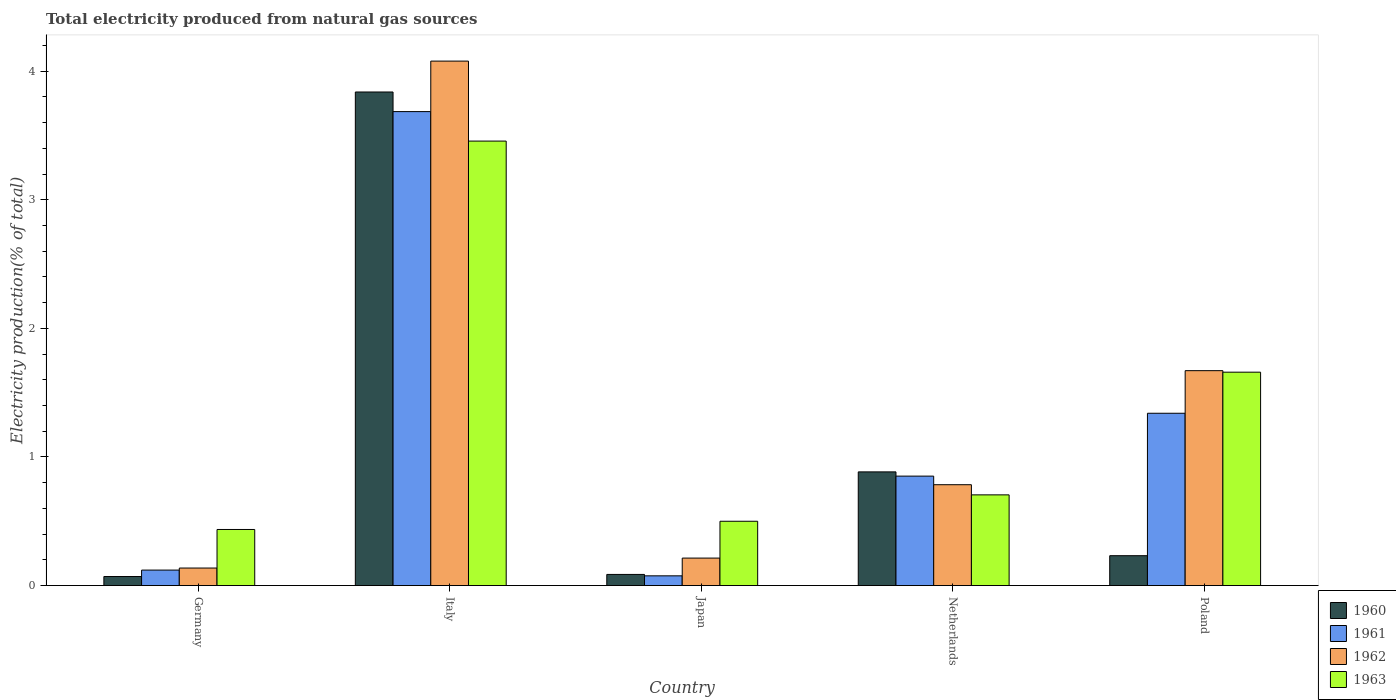How many groups of bars are there?
Make the answer very short. 5. Are the number of bars per tick equal to the number of legend labels?
Your answer should be compact. Yes. How many bars are there on the 3rd tick from the right?
Make the answer very short. 4. What is the total electricity produced in 1962 in Japan?
Offer a terse response. 0.21. Across all countries, what is the maximum total electricity produced in 1962?
Offer a very short reply. 4.08. Across all countries, what is the minimum total electricity produced in 1962?
Your answer should be compact. 0.14. In which country was the total electricity produced in 1960 minimum?
Give a very brief answer. Germany. What is the total total electricity produced in 1961 in the graph?
Provide a succinct answer. 6.07. What is the difference between the total electricity produced in 1961 in Germany and that in Italy?
Offer a terse response. -3.57. What is the difference between the total electricity produced in 1961 in Poland and the total electricity produced in 1963 in Japan?
Provide a short and direct response. 0.84. What is the average total electricity produced in 1960 per country?
Offer a very short reply. 1.02. What is the difference between the total electricity produced of/in 1963 and total electricity produced of/in 1960 in Poland?
Provide a succinct answer. 1.43. What is the ratio of the total electricity produced in 1960 in Germany to that in Japan?
Your response must be concise. 0.81. What is the difference between the highest and the second highest total electricity produced in 1962?
Provide a short and direct response. -0.89. What is the difference between the highest and the lowest total electricity produced in 1960?
Your response must be concise. 3.77. In how many countries, is the total electricity produced in 1960 greater than the average total electricity produced in 1960 taken over all countries?
Make the answer very short. 1. Is the sum of the total electricity produced in 1962 in Italy and Japan greater than the maximum total electricity produced in 1961 across all countries?
Your answer should be very brief. Yes. Is it the case that in every country, the sum of the total electricity produced in 1963 and total electricity produced in 1962 is greater than the sum of total electricity produced in 1960 and total electricity produced in 1961?
Offer a terse response. No. What does the 2nd bar from the left in Italy represents?
Offer a terse response. 1961. What does the 3rd bar from the right in Germany represents?
Your response must be concise. 1961. Is it the case that in every country, the sum of the total electricity produced in 1962 and total electricity produced in 1963 is greater than the total electricity produced in 1961?
Offer a very short reply. Yes. Are all the bars in the graph horizontal?
Provide a short and direct response. No. How many countries are there in the graph?
Provide a short and direct response. 5. What is the difference between two consecutive major ticks on the Y-axis?
Your response must be concise. 1. What is the title of the graph?
Offer a terse response. Total electricity produced from natural gas sources. What is the label or title of the Y-axis?
Make the answer very short. Electricity production(% of total). What is the Electricity production(% of total) of 1960 in Germany?
Offer a very short reply. 0.07. What is the Electricity production(% of total) in 1961 in Germany?
Provide a short and direct response. 0.12. What is the Electricity production(% of total) in 1962 in Germany?
Provide a short and direct response. 0.14. What is the Electricity production(% of total) in 1963 in Germany?
Provide a short and direct response. 0.44. What is the Electricity production(% of total) in 1960 in Italy?
Make the answer very short. 3.84. What is the Electricity production(% of total) in 1961 in Italy?
Provide a succinct answer. 3.69. What is the Electricity production(% of total) in 1962 in Italy?
Provide a succinct answer. 4.08. What is the Electricity production(% of total) in 1963 in Italy?
Ensure brevity in your answer.  3.46. What is the Electricity production(% of total) of 1960 in Japan?
Provide a succinct answer. 0.09. What is the Electricity production(% of total) of 1961 in Japan?
Keep it short and to the point. 0.08. What is the Electricity production(% of total) of 1962 in Japan?
Offer a terse response. 0.21. What is the Electricity production(% of total) in 1963 in Japan?
Your answer should be very brief. 0.5. What is the Electricity production(% of total) in 1960 in Netherlands?
Your response must be concise. 0.88. What is the Electricity production(% of total) in 1961 in Netherlands?
Your response must be concise. 0.85. What is the Electricity production(% of total) of 1962 in Netherlands?
Provide a short and direct response. 0.78. What is the Electricity production(% of total) of 1963 in Netherlands?
Ensure brevity in your answer.  0.71. What is the Electricity production(% of total) of 1960 in Poland?
Your answer should be compact. 0.23. What is the Electricity production(% of total) in 1961 in Poland?
Offer a very short reply. 1.34. What is the Electricity production(% of total) of 1962 in Poland?
Give a very brief answer. 1.67. What is the Electricity production(% of total) of 1963 in Poland?
Keep it short and to the point. 1.66. Across all countries, what is the maximum Electricity production(% of total) of 1960?
Your response must be concise. 3.84. Across all countries, what is the maximum Electricity production(% of total) of 1961?
Provide a short and direct response. 3.69. Across all countries, what is the maximum Electricity production(% of total) of 1962?
Provide a succinct answer. 4.08. Across all countries, what is the maximum Electricity production(% of total) of 1963?
Provide a succinct answer. 3.46. Across all countries, what is the minimum Electricity production(% of total) of 1960?
Provide a succinct answer. 0.07. Across all countries, what is the minimum Electricity production(% of total) of 1961?
Give a very brief answer. 0.08. Across all countries, what is the minimum Electricity production(% of total) in 1962?
Ensure brevity in your answer.  0.14. Across all countries, what is the minimum Electricity production(% of total) of 1963?
Keep it short and to the point. 0.44. What is the total Electricity production(% of total) of 1960 in the graph?
Ensure brevity in your answer.  5.11. What is the total Electricity production(% of total) in 1961 in the graph?
Your answer should be compact. 6.07. What is the total Electricity production(% of total) of 1962 in the graph?
Offer a terse response. 6.88. What is the total Electricity production(% of total) in 1963 in the graph?
Your answer should be very brief. 6.76. What is the difference between the Electricity production(% of total) in 1960 in Germany and that in Italy?
Keep it short and to the point. -3.77. What is the difference between the Electricity production(% of total) in 1961 in Germany and that in Italy?
Your answer should be very brief. -3.57. What is the difference between the Electricity production(% of total) in 1962 in Germany and that in Italy?
Your answer should be very brief. -3.94. What is the difference between the Electricity production(% of total) of 1963 in Germany and that in Italy?
Keep it short and to the point. -3.02. What is the difference between the Electricity production(% of total) of 1960 in Germany and that in Japan?
Provide a short and direct response. -0.02. What is the difference between the Electricity production(% of total) of 1961 in Germany and that in Japan?
Give a very brief answer. 0.04. What is the difference between the Electricity production(% of total) of 1962 in Germany and that in Japan?
Ensure brevity in your answer.  -0.08. What is the difference between the Electricity production(% of total) in 1963 in Germany and that in Japan?
Ensure brevity in your answer.  -0.06. What is the difference between the Electricity production(% of total) in 1960 in Germany and that in Netherlands?
Make the answer very short. -0.81. What is the difference between the Electricity production(% of total) in 1961 in Germany and that in Netherlands?
Give a very brief answer. -0.73. What is the difference between the Electricity production(% of total) of 1962 in Germany and that in Netherlands?
Give a very brief answer. -0.65. What is the difference between the Electricity production(% of total) in 1963 in Germany and that in Netherlands?
Keep it short and to the point. -0.27. What is the difference between the Electricity production(% of total) in 1960 in Germany and that in Poland?
Give a very brief answer. -0.16. What is the difference between the Electricity production(% of total) of 1961 in Germany and that in Poland?
Keep it short and to the point. -1.22. What is the difference between the Electricity production(% of total) in 1962 in Germany and that in Poland?
Make the answer very short. -1.53. What is the difference between the Electricity production(% of total) of 1963 in Germany and that in Poland?
Your answer should be very brief. -1.22. What is the difference between the Electricity production(% of total) in 1960 in Italy and that in Japan?
Your answer should be compact. 3.75. What is the difference between the Electricity production(% of total) in 1961 in Italy and that in Japan?
Keep it short and to the point. 3.61. What is the difference between the Electricity production(% of total) in 1962 in Italy and that in Japan?
Give a very brief answer. 3.86. What is the difference between the Electricity production(% of total) in 1963 in Italy and that in Japan?
Offer a terse response. 2.96. What is the difference between the Electricity production(% of total) in 1960 in Italy and that in Netherlands?
Your answer should be very brief. 2.95. What is the difference between the Electricity production(% of total) of 1961 in Italy and that in Netherlands?
Keep it short and to the point. 2.83. What is the difference between the Electricity production(% of total) of 1962 in Italy and that in Netherlands?
Offer a very short reply. 3.29. What is the difference between the Electricity production(% of total) in 1963 in Italy and that in Netherlands?
Offer a very short reply. 2.75. What is the difference between the Electricity production(% of total) of 1960 in Italy and that in Poland?
Offer a terse response. 3.61. What is the difference between the Electricity production(% of total) in 1961 in Italy and that in Poland?
Make the answer very short. 2.35. What is the difference between the Electricity production(% of total) in 1962 in Italy and that in Poland?
Provide a short and direct response. 2.41. What is the difference between the Electricity production(% of total) of 1963 in Italy and that in Poland?
Give a very brief answer. 1.8. What is the difference between the Electricity production(% of total) of 1960 in Japan and that in Netherlands?
Your response must be concise. -0.8. What is the difference between the Electricity production(% of total) in 1961 in Japan and that in Netherlands?
Your answer should be very brief. -0.78. What is the difference between the Electricity production(% of total) in 1962 in Japan and that in Netherlands?
Give a very brief answer. -0.57. What is the difference between the Electricity production(% of total) of 1963 in Japan and that in Netherlands?
Ensure brevity in your answer.  -0.21. What is the difference between the Electricity production(% of total) in 1960 in Japan and that in Poland?
Your answer should be compact. -0.15. What is the difference between the Electricity production(% of total) in 1961 in Japan and that in Poland?
Your answer should be very brief. -1.26. What is the difference between the Electricity production(% of total) of 1962 in Japan and that in Poland?
Your response must be concise. -1.46. What is the difference between the Electricity production(% of total) in 1963 in Japan and that in Poland?
Offer a very short reply. -1.16. What is the difference between the Electricity production(% of total) of 1960 in Netherlands and that in Poland?
Provide a succinct answer. 0.65. What is the difference between the Electricity production(% of total) of 1961 in Netherlands and that in Poland?
Your answer should be very brief. -0.49. What is the difference between the Electricity production(% of total) in 1962 in Netherlands and that in Poland?
Give a very brief answer. -0.89. What is the difference between the Electricity production(% of total) of 1963 in Netherlands and that in Poland?
Provide a short and direct response. -0.95. What is the difference between the Electricity production(% of total) of 1960 in Germany and the Electricity production(% of total) of 1961 in Italy?
Your response must be concise. -3.62. What is the difference between the Electricity production(% of total) of 1960 in Germany and the Electricity production(% of total) of 1962 in Italy?
Provide a succinct answer. -4.01. What is the difference between the Electricity production(% of total) in 1960 in Germany and the Electricity production(% of total) in 1963 in Italy?
Make the answer very short. -3.39. What is the difference between the Electricity production(% of total) of 1961 in Germany and the Electricity production(% of total) of 1962 in Italy?
Your answer should be compact. -3.96. What is the difference between the Electricity production(% of total) in 1961 in Germany and the Electricity production(% of total) in 1963 in Italy?
Your response must be concise. -3.34. What is the difference between the Electricity production(% of total) in 1962 in Germany and the Electricity production(% of total) in 1963 in Italy?
Offer a terse response. -3.32. What is the difference between the Electricity production(% of total) in 1960 in Germany and the Electricity production(% of total) in 1961 in Japan?
Give a very brief answer. -0.01. What is the difference between the Electricity production(% of total) of 1960 in Germany and the Electricity production(% of total) of 1962 in Japan?
Give a very brief answer. -0.14. What is the difference between the Electricity production(% of total) of 1960 in Germany and the Electricity production(% of total) of 1963 in Japan?
Give a very brief answer. -0.43. What is the difference between the Electricity production(% of total) of 1961 in Germany and the Electricity production(% of total) of 1962 in Japan?
Ensure brevity in your answer.  -0.09. What is the difference between the Electricity production(% of total) of 1961 in Germany and the Electricity production(% of total) of 1963 in Japan?
Your answer should be very brief. -0.38. What is the difference between the Electricity production(% of total) of 1962 in Germany and the Electricity production(% of total) of 1963 in Japan?
Your response must be concise. -0.36. What is the difference between the Electricity production(% of total) of 1960 in Germany and the Electricity production(% of total) of 1961 in Netherlands?
Offer a very short reply. -0.78. What is the difference between the Electricity production(% of total) of 1960 in Germany and the Electricity production(% of total) of 1962 in Netherlands?
Your answer should be compact. -0.71. What is the difference between the Electricity production(% of total) in 1960 in Germany and the Electricity production(% of total) in 1963 in Netherlands?
Your response must be concise. -0.64. What is the difference between the Electricity production(% of total) in 1961 in Germany and the Electricity production(% of total) in 1962 in Netherlands?
Offer a terse response. -0.66. What is the difference between the Electricity production(% of total) in 1961 in Germany and the Electricity production(% of total) in 1963 in Netherlands?
Ensure brevity in your answer.  -0.58. What is the difference between the Electricity production(% of total) of 1962 in Germany and the Electricity production(% of total) of 1963 in Netherlands?
Give a very brief answer. -0.57. What is the difference between the Electricity production(% of total) of 1960 in Germany and the Electricity production(% of total) of 1961 in Poland?
Your answer should be very brief. -1.27. What is the difference between the Electricity production(% of total) of 1960 in Germany and the Electricity production(% of total) of 1962 in Poland?
Offer a very short reply. -1.6. What is the difference between the Electricity production(% of total) of 1960 in Germany and the Electricity production(% of total) of 1963 in Poland?
Provide a succinct answer. -1.59. What is the difference between the Electricity production(% of total) in 1961 in Germany and the Electricity production(% of total) in 1962 in Poland?
Your answer should be compact. -1.55. What is the difference between the Electricity production(% of total) of 1961 in Germany and the Electricity production(% of total) of 1963 in Poland?
Your response must be concise. -1.54. What is the difference between the Electricity production(% of total) of 1962 in Germany and the Electricity production(% of total) of 1963 in Poland?
Offer a very short reply. -1.52. What is the difference between the Electricity production(% of total) in 1960 in Italy and the Electricity production(% of total) in 1961 in Japan?
Give a very brief answer. 3.76. What is the difference between the Electricity production(% of total) of 1960 in Italy and the Electricity production(% of total) of 1962 in Japan?
Offer a very short reply. 3.62. What is the difference between the Electricity production(% of total) of 1960 in Italy and the Electricity production(% of total) of 1963 in Japan?
Give a very brief answer. 3.34. What is the difference between the Electricity production(% of total) in 1961 in Italy and the Electricity production(% of total) in 1962 in Japan?
Ensure brevity in your answer.  3.47. What is the difference between the Electricity production(% of total) in 1961 in Italy and the Electricity production(% of total) in 1963 in Japan?
Offer a terse response. 3.19. What is the difference between the Electricity production(% of total) in 1962 in Italy and the Electricity production(% of total) in 1963 in Japan?
Offer a terse response. 3.58. What is the difference between the Electricity production(% of total) of 1960 in Italy and the Electricity production(% of total) of 1961 in Netherlands?
Ensure brevity in your answer.  2.99. What is the difference between the Electricity production(% of total) in 1960 in Italy and the Electricity production(% of total) in 1962 in Netherlands?
Your response must be concise. 3.05. What is the difference between the Electricity production(% of total) in 1960 in Italy and the Electricity production(% of total) in 1963 in Netherlands?
Provide a succinct answer. 3.13. What is the difference between the Electricity production(% of total) in 1961 in Italy and the Electricity production(% of total) in 1962 in Netherlands?
Make the answer very short. 2.9. What is the difference between the Electricity production(% of total) in 1961 in Italy and the Electricity production(% of total) in 1963 in Netherlands?
Your answer should be compact. 2.98. What is the difference between the Electricity production(% of total) in 1962 in Italy and the Electricity production(% of total) in 1963 in Netherlands?
Provide a short and direct response. 3.37. What is the difference between the Electricity production(% of total) of 1960 in Italy and the Electricity production(% of total) of 1961 in Poland?
Keep it short and to the point. 2.5. What is the difference between the Electricity production(% of total) in 1960 in Italy and the Electricity production(% of total) in 1962 in Poland?
Make the answer very short. 2.17. What is the difference between the Electricity production(% of total) of 1960 in Italy and the Electricity production(% of total) of 1963 in Poland?
Provide a succinct answer. 2.18. What is the difference between the Electricity production(% of total) in 1961 in Italy and the Electricity production(% of total) in 1962 in Poland?
Keep it short and to the point. 2.01. What is the difference between the Electricity production(% of total) in 1961 in Italy and the Electricity production(% of total) in 1963 in Poland?
Ensure brevity in your answer.  2.03. What is the difference between the Electricity production(% of total) of 1962 in Italy and the Electricity production(% of total) of 1963 in Poland?
Provide a succinct answer. 2.42. What is the difference between the Electricity production(% of total) in 1960 in Japan and the Electricity production(% of total) in 1961 in Netherlands?
Provide a succinct answer. -0.76. What is the difference between the Electricity production(% of total) of 1960 in Japan and the Electricity production(% of total) of 1962 in Netherlands?
Your answer should be compact. -0.7. What is the difference between the Electricity production(% of total) of 1960 in Japan and the Electricity production(% of total) of 1963 in Netherlands?
Keep it short and to the point. -0.62. What is the difference between the Electricity production(% of total) in 1961 in Japan and the Electricity production(% of total) in 1962 in Netherlands?
Make the answer very short. -0.71. What is the difference between the Electricity production(% of total) in 1961 in Japan and the Electricity production(% of total) in 1963 in Netherlands?
Your answer should be compact. -0.63. What is the difference between the Electricity production(% of total) of 1962 in Japan and the Electricity production(% of total) of 1963 in Netherlands?
Provide a succinct answer. -0.49. What is the difference between the Electricity production(% of total) in 1960 in Japan and the Electricity production(% of total) in 1961 in Poland?
Keep it short and to the point. -1.25. What is the difference between the Electricity production(% of total) of 1960 in Japan and the Electricity production(% of total) of 1962 in Poland?
Your response must be concise. -1.58. What is the difference between the Electricity production(% of total) in 1960 in Japan and the Electricity production(% of total) in 1963 in Poland?
Give a very brief answer. -1.57. What is the difference between the Electricity production(% of total) in 1961 in Japan and the Electricity production(% of total) in 1962 in Poland?
Make the answer very short. -1.6. What is the difference between the Electricity production(% of total) in 1961 in Japan and the Electricity production(% of total) in 1963 in Poland?
Keep it short and to the point. -1.58. What is the difference between the Electricity production(% of total) of 1962 in Japan and the Electricity production(% of total) of 1963 in Poland?
Offer a very short reply. -1.45. What is the difference between the Electricity production(% of total) of 1960 in Netherlands and the Electricity production(% of total) of 1961 in Poland?
Provide a short and direct response. -0.46. What is the difference between the Electricity production(% of total) of 1960 in Netherlands and the Electricity production(% of total) of 1962 in Poland?
Keep it short and to the point. -0.79. What is the difference between the Electricity production(% of total) of 1960 in Netherlands and the Electricity production(% of total) of 1963 in Poland?
Offer a terse response. -0.78. What is the difference between the Electricity production(% of total) in 1961 in Netherlands and the Electricity production(% of total) in 1962 in Poland?
Your answer should be very brief. -0.82. What is the difference between the Electricity production(% of total) in 1961 in Netherlands and the Electricity production(% of total) in 1963 in Poland?
Your answer should be very brief. -0.81. What is the difference between the Electricity production(% of total) of 1962 in Netherlands and the Electricity production(% of total) of 1963 in Poland?
Provide a succinct answer. -0.88. What is the average Electricity production(% of total) of 1960 per country?
Your response must be concise. 1.02. What is the average Electricity production(% of total) of 1961 per country?
Your answer should be very brief. 1.21. What is the average Electricity production(% of total) of 1962 per country?
Your response must be concise. 1.38. What is the average Electricity production(% of total) in 1963 per country?
Give a very brief answer. 1.35. What is the difference between the Electricity production(% of total) of 1960 and Electricity production(% of total) of 1962 in Germany?
Make the answer very short. -0.07. What is the difference between the Electricity production(% of total) in 1960 and Electricity production(% of total) in 1963 in Germany?
Offer a very short reply. -0.37. What is the difference between the Electricity production(% of total) of 1961 and Electricity production(% of total) of 1962 in Germany?
Offer a terse response. -0.02. What is the difference between the Electricity production(% of total) of 1961 and Electricity production(% of total) of 1963 in Germany?
Ensure brevity in your answer.  -0.32. What is the difference between the Electricity production(% of total) in 1962 and Electricity production(% of total) in 1963 in Germany?
Ensure brevity in your answer.  -0.3. What is the difference between the Electricity production(% of total) of 1960 and Electricity production(% of total) of 1961 in Italy?
Keep it short and to the point. 0.15. What is the difference between the Electricity production(% of total) of 1960 and Electricity production(% of total) of 1962 in Italy?
Your response must be concise. -0.24. What is the difference between the Electricity production(% of total) in 1960 and Electricity production(% of total) in 1963 in Italy?
Offer a terse response. 0.38. What is the difference between the Electricity production(% of total) in 1961 and Electricity production(% of total) in 1962 in Italy?
Provide a succinct answer. -0.39. What is the difference between the Electricity production(% of total) of 1961 and Electricity production(% of total) of 1963 in Italy?
Your answer should be very brief. 0.23. What is the difference between the Electricity production(% of total) of 1962 and Electricity production(% of total) of 1963 in Italy?
Make the answer very short. 0.62. What is the difference between the Electricity production(% of total) of 1960 and Electricity production(% of total) of 1961 in Japan?
Your answer should be very brief. 0.01. What is the difference between the Electricity production(% of total) of 1960 and Electricity production(% of total) of 1962 in Japan?
Keep it short and to the point. -0.13. What is the difference between the Electricity production(% of total) of 1960 and Electricity production(% of total) of 1963 in Japan?
Ensure brevity in your answer.  -0.41. What is the difference between the Electricity production(% of total) of 1961 and Electricity production(% of total) of 1962 in Japan?
Your answer should be compact. -0.14. What is the difference between the Electricity production(% of total) in 1961 and Electricity production(% of total) in 1963 in Japan?
Provide a short and direct response. -0.42. What is the difference between the Electricity production(% of total) of 1962 and Electricity production(% of total) of 1963 in Japan?
Your response must be concise. -0.29. What is the difference between the Electricity production(% of total) of 1960 and Electricity production(% of total) of 1961 in Netherlands?
Ensure brevity in your answer.  0.03. What is the difference between the Electricity production(% of total) in 1960 and Electricity production(% of total) in 1962 in Netherlands?
Keep it short and to the point. 0.1. What is the difference between the Electricity production(% of total) of 1960 and Electricity production(% of total) of 1963 in Netherlands?
Offer a terse response. 0.18. What is the difference between the Electricity production(% of total) in 1961 and Electricity production(% of total) in 1962 in Netherlands?
Your answer should be compact. 0.07. What is the difference between the Electricity production(% of total) in 1961 and Electricity production(% of total) in 1963 in Netherlands?
Offer a very short reply. 0.15. What is the difference between the Electricity production(% of total) in 1962 and Electricity production(% of total) in 1963 in Netherlands?
Offer a very short reply. 0.08. What is the difference between the Electricity production(% of total) in 1960 and Electricity production(% of total) in 1961 in Poland?
Your response must be concise. -1.11. What is the difference between the Electricity production(% of total) in 1960 and Electricity production(% of total) in 1962 in Poland?
Offer a very short reply. -1.44. What is the difference between the Electricity production(% of total) of 1960 and Electricity production(% of total) of 1963 in Poland?
Provide a succinct answer. -1.43. What is the difference between the Electricity production(% of total) of 1961 and Electricity production(% of total) of 1962 in Poland?
Make the answer very short. -0.33. What is the difference between the Electricity production(% of total) of 1961 and Electricity production(% of total) of 1963 in Poland?
Your answer should be very brief. -0.32. What is the difference between the Electricity production(% of total) of 1962 and Electricity production(% of total) of 1963 in Poland?
Give a very brief answer. 0.01. What is the ratio of the Electricity production(% of total) of 1960 in Germany to that in Italy?
Make the answer very short. 0.02. What is the ratio of the Electricity production(% of total) of 1961 in Germany to that in Italy?
Provide a succinct answer. 0.03. What is the ratio of the Electricity production(% of total) in 1962 in Germany to that in Italy?
Provide a short and direct response. 0.03. What is the ratio of the Electricity production(% of total) in 1963 in Germany to that in Italy?
Make the answer very short. 0.13. What is the ratio of the Electricity production(% of total) in 1960 in Germany to that in Japan?
Your answer should be very brief. 0.81. What is the ratio of the Electricity production(% of total) in 1961 in Germany to that in Japan?
Your response must be concise. 1.59. What is the ratio of the Electricity production(% of total) in 1962 in Germany to that in Japan?
Make the answer very short. 0.64. What is the ratio of the Electricity production(% of total) of 1963 in Germany to that in Japan?
Ensure brevity in your answer.  0.87. What is the ratio of the Electricity production(% of total) in 1960 in Germany to that in Netherlands?
Your response must be concise. 0.08. What is the ratio of the Electricity production(% of total) of 1961 in Germany to that in Netherlands?
Make the answer very short. 0.14. What is the ratio of the Electricity production(% of total) in 1962 in Germany to that in Netherlands?
Keep it short and to the point. 0.17. What is the ratio of the Electricity production(% of total) of 1963 in Germany to that in Netherlands?
Provide a short and direct response. 0.62. What is the ratio of the Electricity production(% of total) of 1960 in Germany to that in Poland?
Your answer should be very brief. 0.3. What is the ratio of the Electricity production(% of total) of 1961 in Germany to that in Poland?
Offer a very short reply. 0.09. What is the ratio of the Electricity production(% of total) in 1962 in Germany to that in Poland?
Your answer should be very brief. 0.08. What is the ratio of the Electricity production(% of total) in 1963 in Germany to that in Poland?
Offer a terse response. 0.26. What is the ratio of the Electricity production(% of total) of 1960 in Italy to that in Japan?
Provide a short and direct response. 44.33. What is the ratio of the Electricity production(% of total) of 1961 in Italy to that in Japan?
Offer a very short reply. 48.69. What is the ratio of the Electricity production(% of total) of 1962 in Italy to that in Japan?
Provide a short and direct response. 19.09. What is the ratio of the Electricity production(% of total) of 1963 in Italy to that in Japan?
Provide a short and direct response. 6.91. What is the ratio of the Electricity production(% of total) of 1960 in Italy to that in Netherlands?
Offer a very short reply. 4.34. What is the ratio of the Electricity production(% of total) in 1961 in Italy to that in Netherlands?
Give a very brief answer. 4.33. What is the ratio of the Electricity production(% of total) in 1962 in Italy to that in Netherlands?
Your answer should be compact. 5.2. What is the ratio of the Electricity production(% of total) in 1963 in Italy to that in Netherlands?
Provide a succinct answer. 4.9. What is the ratio of the Electricity production(% of total) in 1960 in Italy to that in Poland?
Offer a very short reply. 16.53. What is the ratio of the Electricity production(% of total) in 1961 in Italy to that in Poland?
Ensure brevity in your answer.  2.75. What is the ratio of the Electricity production(% of total) of 1962 in Italy to that in Poland?
Your response must be concise. 2.44. What is the ratio of the Electricity production(% of total) of 1963 in Italy to that in Poland?
Make the answer very short. 2.08. What is the ratio of the Electricity production(% of total) of 1960 in Japan to that in Netherlands?
Ensure brevity in your answer.  0.1. What is the ratio of the Electricity production(% of total) of 1961 in Japan to that in Netherlands?
Your response must be concise. 0.09. What is the ratio of the Electricity production(% of total) in 1962 in Japan to that in Netherlands?
Ensure brevity in your answer.  0.27. What is the ratio of the Electricity production(% of total) in 1963 in Japan to that in Netherlands?
Provide a succinct answer. 0.71. What is the ratio of the Electricity production(% of total) of 1960 in Japan to that in Poland?
Make the answer very short. 0.37. What is the ratio of the Electricity production(% of total) of 1961 in Japan to that in Poland?
Keep it short and to the point. 0.06. What is the ratio of the Electricity production(% of total) in 1962 in Japan to that in Poland?
Ensure brevity in your answer.  0.13. What is the ratio of the Electricity production(% of total) in 1963 in Japan to that in Poland?
Provide a short and direct response. 0.3. What is the ratio of the Electricity production(% of total) of 1960 in Netherlands to that in Poland?
Ensure brevity in your answer.  3.81. What is the ratio of the Electricity production(% of total) in 1961 in Netherlands to that in Poland?
Provide a succinct answer. 0.64. What is the ratio of the Electricity production(% of total) of 1962 in Netherlands to that in Poland?
Provide a short and direct response. 0.47. What is the ratio of the Electricity production(% of total) in 1963 in Netherlands to that in Poland?
Keep it short and to the point. 0.42. What is the difference between the highest and the second highest Electricity production(% of total) of 1960?
Offer a terse response. 2.95. What is the difference between the highest and the second highest Electricity production(% of total) in 1961?
Provide a succinct answer. 2.35. What is the difference between the highest and the second highest Electricity production(% of total) in 1962?
Your response must be concise. 2.41. What is the difference between the highest and the second highest Electricity production(% of total) in 1963?
Offer a very short reply. 1.8. What is the difference between the highest and the lowest Electricity production(% of total) of 1960?
Offer a very short reply. 3.77. What is the difference between the highest and the lowest Electricity production(% of total) of 1961?
Your answer should be compact. 3.61. What is the difference between the highest and the lowest Electricity production(% of total) in 1962?
Keep it short and to the point. 3.94. What is the difference between the highest and the lowest Electricity production(% of total) in 1963?
Make the answer very short. 3.02. 